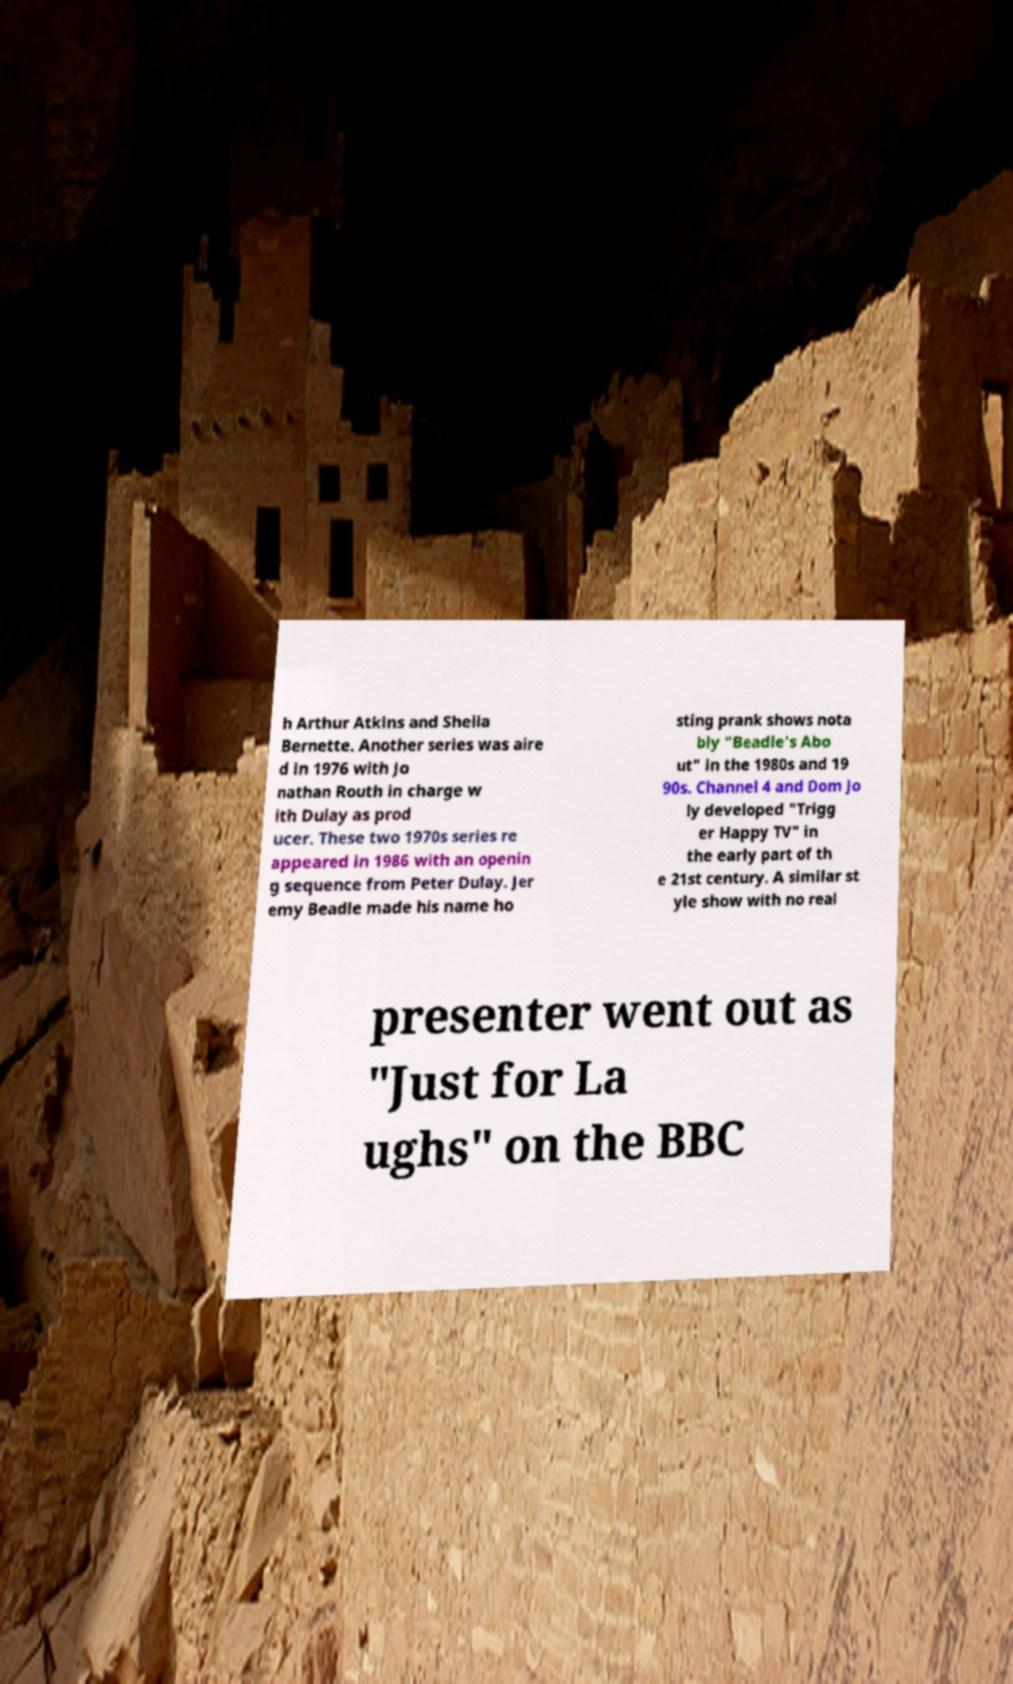Can you accurately transcribe the text from the provided image for me? h Arthur Atkins and Sheila Bernette. Another series was aire d in 1976 with Jo nathan Routh in charge w ith Dulay as prod ucer. These two 1970s series re appeared in 1986 with an openin g sequence from Peter Dulay. Jer emy Beadle made his name ho sting prank shows nota bly "Beadle's Abo ut" in the 1980s and 19 90s. Channel 4 and Dom Jo ly developed "Trigg er Happy TV" in the early part of th e 21st century. A similar st yle show with no real presenter went out as "Just for La ughs" on the BBC 